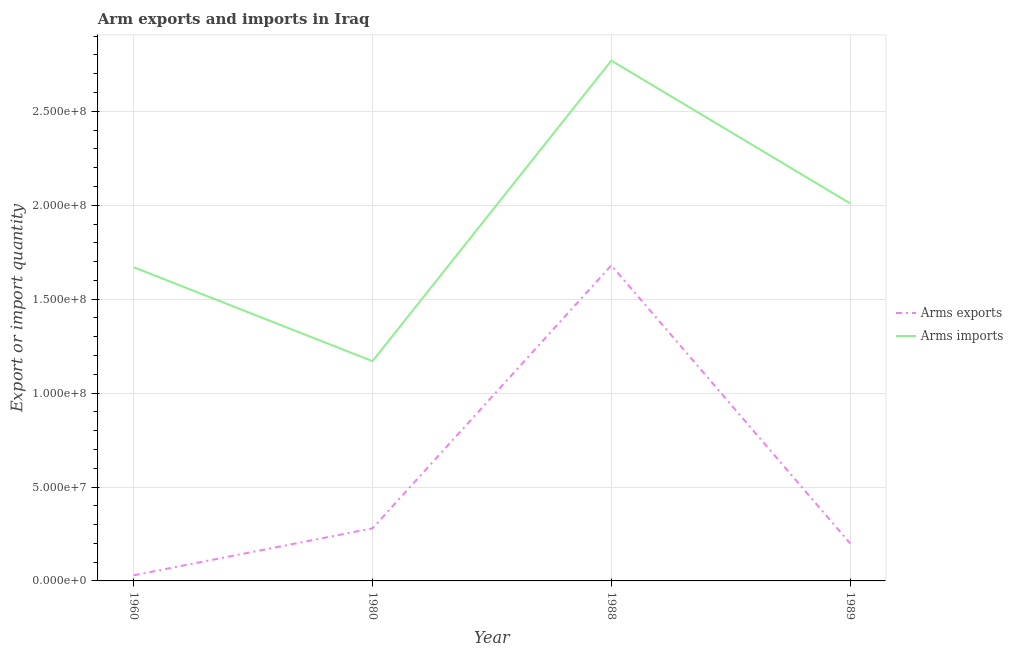How many different coloured lines are there?
Keep it short and to the point. 2. What is the arms exports in 1988?
Offer a very short reply. 1.68e+08. Across all years, what is the maximum arms imports?
Provide a succinct answer. 2.77e+08. Across all years, what is the minimum arms imports?
Offer a very short reply. 1.17e+08. In which year was the arms imports minimum?
Your response must be concise. 1980. What is the total arms imports in the graph?
Your answer should be compact. 7.62e+08. What is the difference between the arms exports in 1980 and that in 1989?
Make the answer very short. 8.00e+06. What is the difference between the arms imports in 1989 and the arms exports in 1988?
Provide a short and direct response. 3.30e+07. What is the average arms exports per year?
Make the answer very short. 5.48e+07. In the year 1960, what is the difference between the arms exports and arms imports?
Provide a succinct answer. -1.64e+08. In how many years, is the arms imports greater than 140000000?
Provide a succinct answer. 3. What is the ratio of the arms exports in 1988 to that in 1989?
Your answer should be very brief. 8.4. What is the difference between the highest and the second highest arms exports?
Your answer should be very brief. 1.40e+08. What is the difference between the highest and the lowest arms imports?
Provide a succinct answer. 1.60e+08. In how many years, is the arms imports greater than the average arms imports taken over all years?
Your answer should be compact. 2. Is the sum of the arms exports in 1960 and 1989 greater than the maximum arms imports across all years?
Give a very brief answer. No. Is the arms exports strictly less than the arms imports over the years?
Your answer should be very brief. Yes. How many years are there in the graph?
Your response must be concise. 4. What is the difference between two consecutive major ticks on the Y-axis?
Give a very brief answer. 5.00e+07. Does the graph contain any zero values?
Provide a short and direct response. No. Where does the legend appear in the graph?
Ensure brevity in your answer.  Center right. How many legend labels are there?
Make the answer very short. 2. How are the legend labels stacked?
Provide a short and direct response. Vertical. What is the title of the graph?
Your response must be concise. Arm exports and imports in Iraq. Does "IMF nonconcessional" appear as one of the legend labels in the graph?
Offer a very short reply. No. What is the label or title of the X-axis?
Your response must be concise. Year. What is the label or title of the Y-axis?
Your answer should be very brief. Export or import quantity. What is the Export or import quantity in Arms exports in 1960?
Offer a terse response. 3.00e+06. What is the Export or import quantity in Arms imports in 1960?
Your answer should be compact. 1.67e+08. What is the Export or import quantity in Arms exports in 1980?
Give a very brief answer. 2.80e+07. What is the Export or import quantity of Arms imports in 1980?
Your answer should be compact. 1.17e+08. What is the Export or import quantity of Arms exports in 1988?
Keep it short and to the point. 1.68e+08. What is the Export or import quantity in Arms imports in 1988?
Your answer should be very brief. 2.77e+08. What is the Export or import quantity in Arms imports in 1989?
Provide a short and direct response. 2.01e+08. Across all years, what is the maximum Export or import quantity of Arms exports?
Your answer should be very brief. 1.68e+08. Across all years, what is the maximum Export or import quantity in Arms imports?
Provide a succinct answer. 2.77e+08. Across all years, what is the minimum Export or import quantity in Arms imports?
Give a very brief answer. 1.17e+08. What is the total Export or import quantity of Arms exports in the graph?
Make the answer very short. 2.19e+08. What is the total Export or import quantity in Arms imports in the graph?
Keep it short and to the point. 7.62e+08. What is the difference between the Export or import quantity of Arms exports in 1960 and that in 1980?
Give a very brief answer. -2.50e+07. What is the difference between the Export or import quantity of Arms exports in 1960 and that in 1988?
Your response must be concise. -1.65e+08. What is the difference between the Export or import quantity of Arms imports in 1960 and that in 1988?
Your answer should be very brief. -1.10e+08. What is the difference between the Export or import quantity of Arms exports in 1960 and that in 1989?
Ensure brevity in your answer.  -1.70e+07. What is the difference between the Export or import quantity of Arms imports in 1960 and that in 1989?
Offer a very short reply. -3.40e+07. What is the difference between the Export or import quantity in Arms exports in 1980 and that in 1988?
Your answer should be compact. -1.40e+08. What is the difference between the Export or import quantity in Arms imports in 1980 and that in 1988?
Your answer should be very brief. -1.60e+08. What is the difference between the Export or import quantity in Arms exports in 1980 and that in 1989?
Make the answer very short. 8.00e+06. What is the difference between the Export or import quantity in Arms imports in 1980 and that in 1989?
Keep it short and to the point. -8.40e+07. What is the difference between the Export or import quantity of Arms exports in 1988 and that in 1989?
Your response must be concise. 1.48e+08. What is the difference between the Export or import quantity of Arms imports in 1988 and that in 1989?
Make the answer very short. 7.60e+07. What is the difference between the Export or import quantity in Arms exports in 1960 and the Export or import quantity in Arms imports in 1980?
Provide a succinct answer. -1.14e+08. What is the difference between the Export or import quantity of Arms exports in 1960 and the Export or import quantity of Arms imports in 1988?
Provide a short and direct response. -2.74e+08. What is the difference between the Export or import quantity of Arms exports in 1960 and the Export or import quantity of Arms imports in 1989?
Your response must be concise. -1.98e+08. What is the difference between the Export or import quantity in Arms exports in 1980 and the Export or import quantity in Arms imports in 1988?
Provide a succinct answer. -2.49e+08. What is the difference between the Export or import quantity of Arms exports in 1980 and the Export or import quantity of Arms imports in 1989?
Keep it short and to the point. -1.73e+08. What is the difference between the Export or import quantity of Arms exports in 1988 and the Export or import quantity of Arms imports in 1989?
Your response must be concise. -3.30e+07. What is the average Export or import quantity of Arms exports per year?
Give a very brief answer. 5.48e+07. What is the average Export or import quantity in Arms imports per year?
Give a very brief answer. 1.90e+08. In the year 1960, what is the difference between the Export or import quantity in Arms exports and Export or import quantity in Arms imports?
Offer a terse response. -1.64e+08. In the year 1980, what is the difference between the Export or import quantity in Arms exports and Export or import quantity in Arms imports?
Provide a succinct answer. -8.90e+07. In the year 1988, what is the difference between the Export or import quantity of Arms exports and Export or import quantity of Arms imports?
Keep it short and to the point. -1.09e+08. In the year 1989, what is the difference between the Export or import quantity in Arms exports and Export or import quantity in Arms imports?
Provide a short and direct response. -1.81e+08. What is the ratio of the Export or import quantity in Arms exports in 1960 to that in 1980?
Provide a short and direct response. 0.11. What is the ratio of the Export or import quantity in Arms imports in 1960 to that in 1980?
Your answer should be very brief. 1.43. What is the ratio of the Export or import quantity of Arms exports in 1960 to that in 1988?
Your answer should be compact. 0.02. What is the ratio of the Export or import quantity in Arms imports in 1960 to that in 1988?
Your answer should be very brief. 0.6. What is the ratio of the Export or import quantity of Arms exports in 1960 to that in 1989?
Ensure brevity in your answer.  0.15. What is the ratio of the Export or import quantity in Arms imports in 1960 to that in 1989?
Provide a short and direct response. 0.83. What is the ratio of the Export or import quantity of Arms exports in 1980 to that in 1988?
Your answer should be very brief. 0.17. What is the ratio of the Export or import quantity in Arms imports in 1980 to that in 1988?
Your answer should be very brief. 0.42. What is the ratio of the Export or import quantity in Arms exports in 1980 to that in 1989?
Provide a succinct answer. 1.4. What is the ratio of the Export or import quantity of Arms imports in 1980 to that in 1989?
Offer a very short reply. 0.58. What is the ratio of the Export or import quantity of Arms exports in 1988 to that in 1989?
Ensure brevity in your answer.  8.4. What is the ratio of the Export or import quantity in Arms imports in 1988 to that in 1989?
Give a very brief answer. 1.38. What is the difference between the highest and the second highest Export or import quantity of Arms exports?
Provide a short and direct response. 1.40e+08. What is the difference between the highest and the second highest Export or import quantity of Arms imports?
Make the answer very short. 7.60e+07. What is the difference between the highest and the lowest Export or import quantity of Arms exports?
Your response must be concise. 1.65e+08. What is the difference between the highest and the lowest Export or import quantity of Arms imports?
Provide a succinct answer. 1.60e+08. 